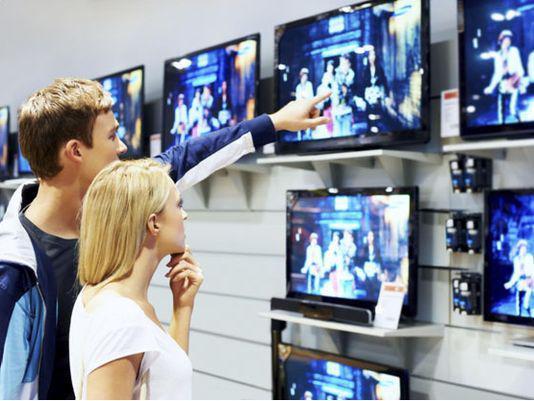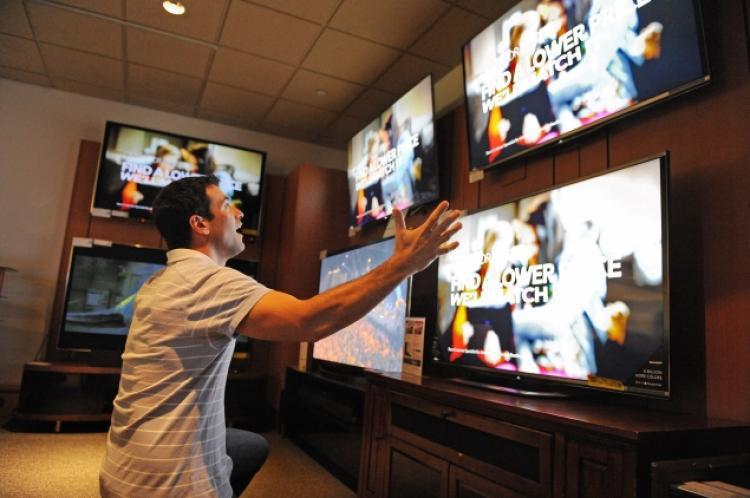The first image is the image on the left, the second image is the image on the right. Analyze the images presented: Is the assertion "In one image, a man and woman are standing together looking at a display television, the man's arm stretched out pointing at the screen." valid? Answer yes or no. Yes. The first image is the image on the left, the second image is the image on the right. For the images shown, is this caption "At least one of the images shows a man with his arm around a woman's shoulder." true? Answer yes or no. No. 